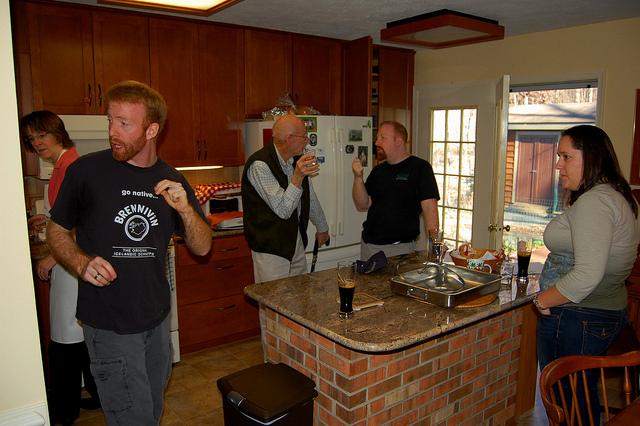What are the people in the photo drinking?
Give a very brief answer. Beer. What is in the basket?
Answer briefly. Bread. What is the kitchen island made from?
Quick response, please. Brick. Is there a party going on?
Short answer required. Yes. What is on the counter?
Write a very short answer. Beer. Why are they standing?
Short answer required. Talking. Is the person on the right a man or woman?
Quick response, please. Woman. How many people are wearing black?
Be succinct. 3. Is this a recent photo?
Write a very short answer. Yes. 